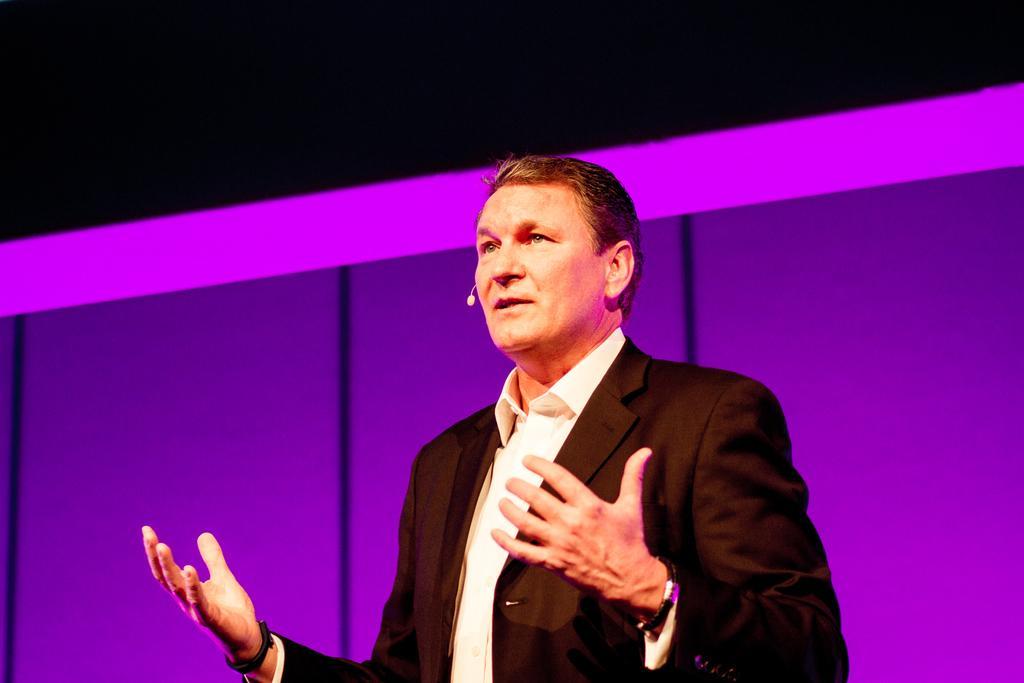In one or two sentences, can you explain what this image depicts? In this image we can see a person standing and wearing a mic. 